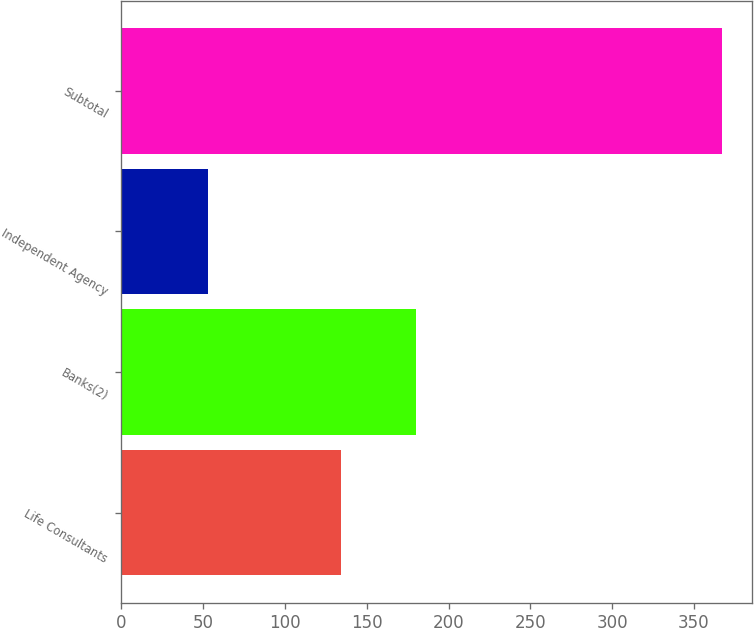Convert chart. <chart><loc_0><loc_0><loc_500><loc_500><bar_chart><fcel>Life Consultants<fcel>Banks(2)<fcel>Independent Agency<fcel>Subtotal<nl><fcel>134<fcel>180<fcel>53<fcel>367<nl></chart> 